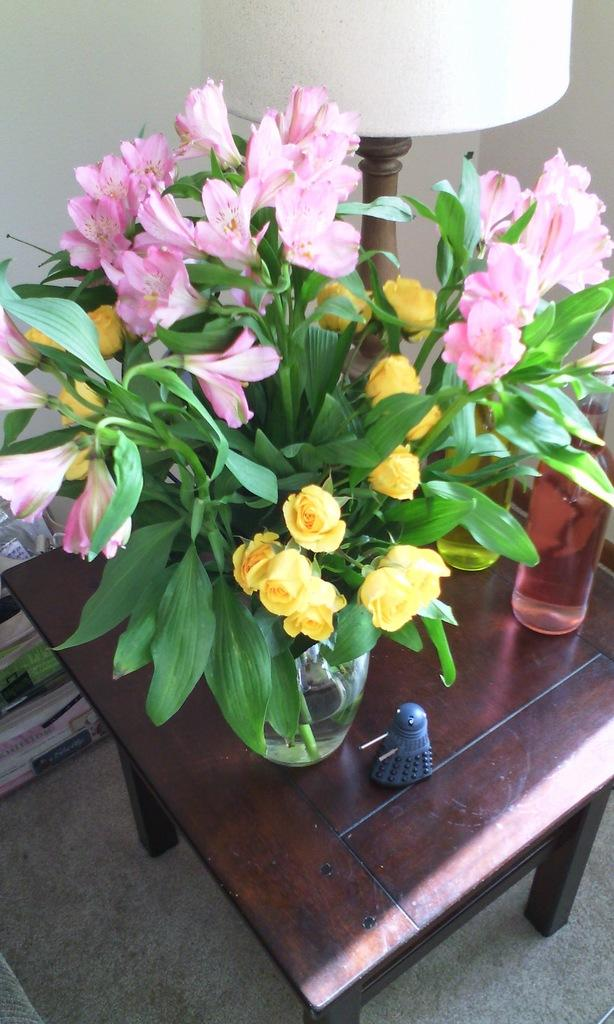What type of living organism can be seen in the image? There is a plant in the image. What object is on the table in the image? There is a bottle on a table in the image. What type of lighting fixture is present in the image? There is a lamp in the image. What is the plant's opinion on the bottle in the image? Plants do not have opinions, as they are living organisms and not capable of forming opinions. 